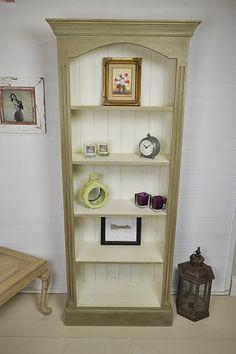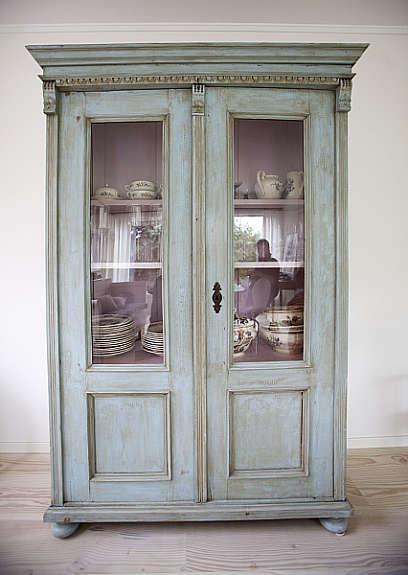The first image is the image on the left, the second image is the image on the right. For the images shown, is this caption "At least one shelving unit is teal." true? Answer yes or no. Yes. The first image is the image on the left, the second image is the image on the right. For the images displayed, is the sentence "One of the cabinets has doors." factually correct? Answer yes or no. Yes. 